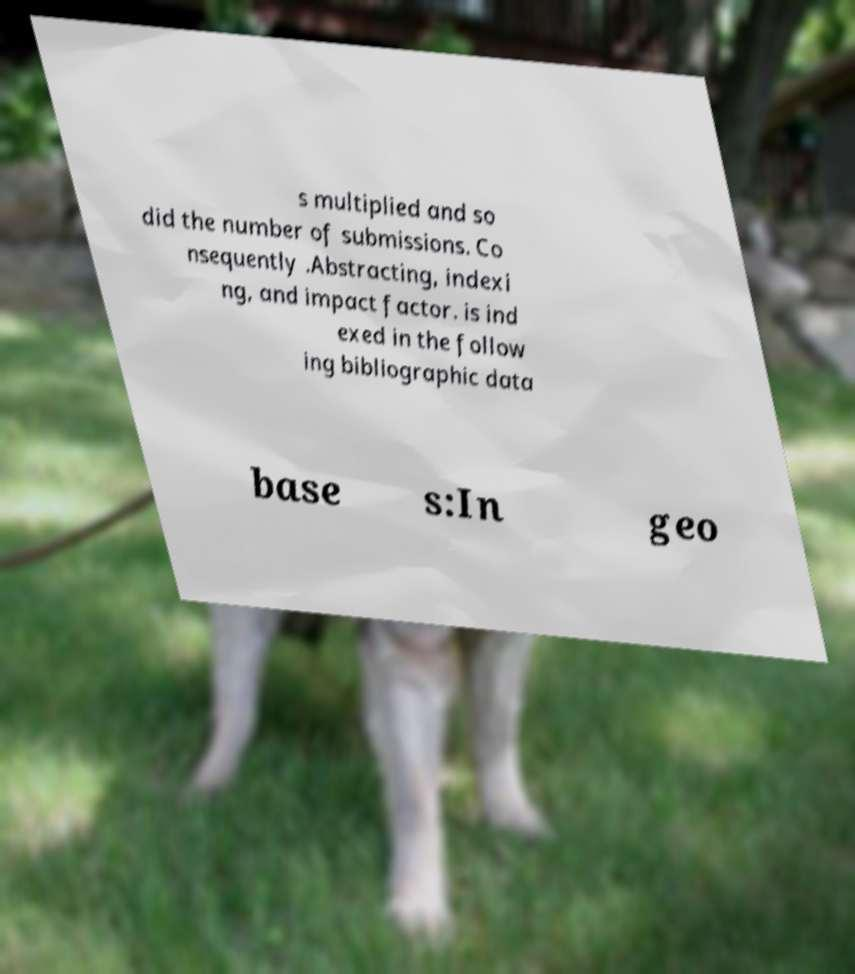Please read and relay the text visible in this image. What does it say? s multiplied and so did the number of submissions. Co nsequently .Abstracting, indexi ng, and impact factor. is ind exed in the follow ing bibliographic data base s:In geo 